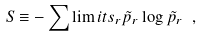Convert formula to latex. <formula><loc_0><loc_0><loc_500><loc_500>S \equiv - \sum \lim i t s _ { r } \tilde { p } _ { r } \log \tilde { p } _ { r } \ ,</formula> 